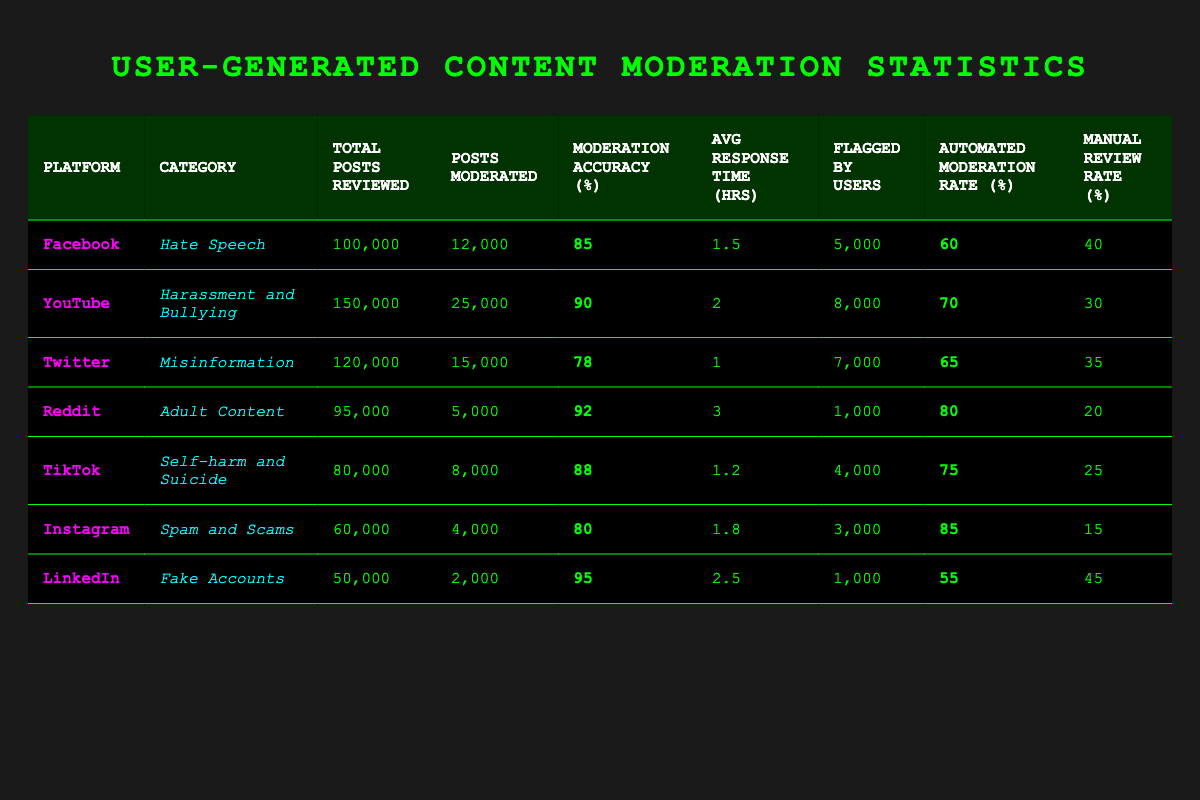What is the moderation accuracy for YouTube? The table shows that the moderation accuracy for YouTube in the category of Harassment and Bullying is listed as 90%.
Answer: 90 Which platform has the lowest number of posts moderated? By reviewing the table, Reddit has the lowest number of posts moderated at 5,000.
Answer: Reddit What is the average response time for spam and scams moderation on Instagram? The table indicates that the average response time for Instagram in the Spam and Scams category is 1.8 hours.
Answer: 1.8 hours Which platform has the highest automated moderation rate? After comparing the automated moderation rates in the table, Instagram has the highest rate at 85%.
Answer: Instagram If we compare the average response times of TikTok and Twitter, which platform is faster? The average response time for TikTok is 1.2 hours while for Twitter it is 1 hour. Since 1 hour is less than 1.2 hours, Twitter is faster.
Answer: Twitter How many total posts were reviewed across all platforms? To find this, sum the Total Posts Reviewed for each platform: 100,000 + 150,000 + 120,000 + 95,000 + 80,000 + 60,000 + 50,000 = 655,000 total posts reviewed.
Answer: 655,000 Is the manual review rate for LinkedIn greater than 40%? The table indicates that LinkedIn's manual review rate is 45%, which is greater than 40%.
Answer: Yes Calculate the average moderation accuracy for all platforms. Sum the Moderation Accuracy for each platform (85 + 90 + 78 + 92 + 88 + 80 + 95 = 518) and divide by 7 (the number of platforms), resulting in an average of approximately 74. The average accuracy is 518/7, which equals 74. Hence, the average moderation accuracy is about 74%.
Answer: 74 How many flagged posts did TikTok have? According to the table, TikTok had 4,000 posts flagged by users.
Answer: 4,000 Which category had the highest number of total posts reviewed? Reviewing the totals, YouTube had the highest number with 150,000 posts reviewed in the Harassment and Bullying category.
Answer: YouTube 